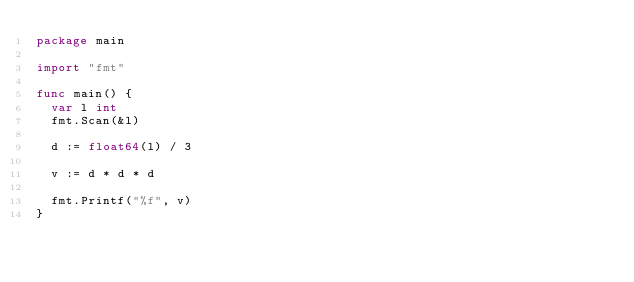Convert code to text. <code><loc_0><loc_0><loc_500><loc_500><_Go_>package main

import "fmt"

func main() {
	var l int
	fmt.Scan(&l)

	d := float64(l) / 3

	v := d * d * d

	fmt.Printf("%f", v)
}
</code> 